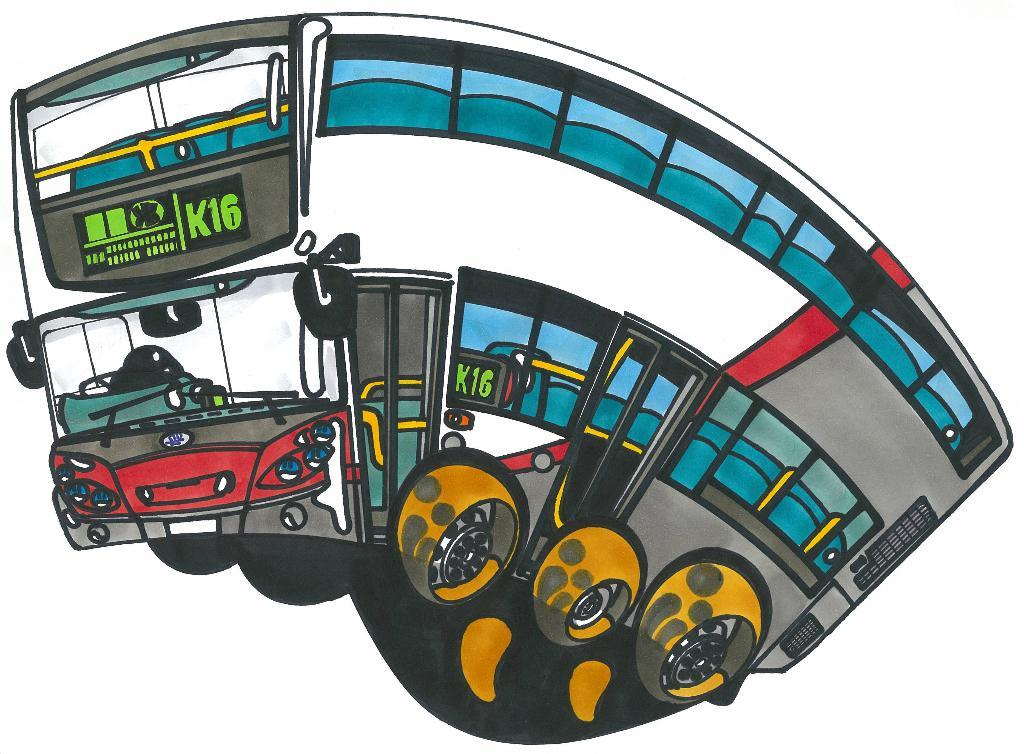What is depicted in the painting in the image? There is a painting of a bus in the image. What can be observed about the use of colors in the painting? Different colors are used in the painting. How many kittens are sitting on the quartz in the image? There are no kittens or quartz present in the image; it features a painting of a bus. 